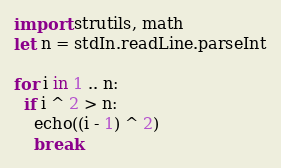Convert code to text. <code><loc_0><loc_0><loc_500><loc_500><_Nim_>import strutils, math
let n = stdIn.readLine.parseInt

for i in 1 .. n:
  if i ^ 2 > n:
    echo((i - 1) ^ 2)
    break
</code> 